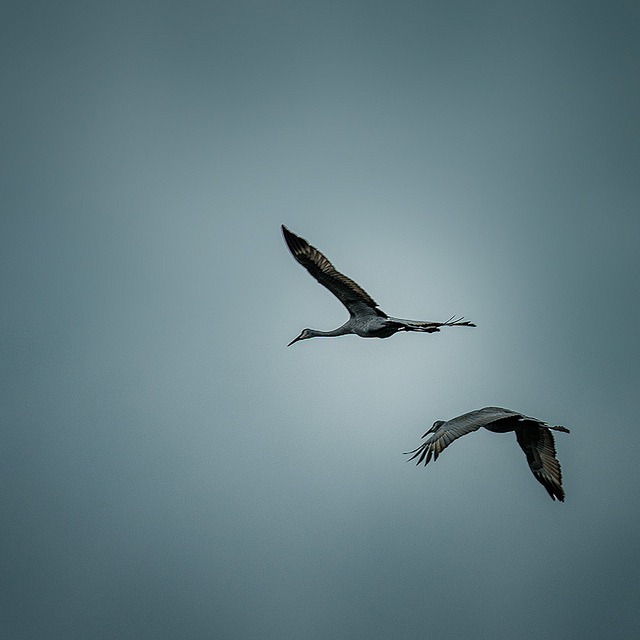<image>Why aren't there any feathers on its neck? It is unclear why there aren't any feathers on its neck. It could be due to a variety of reasons such as the bird was born that way, or they don't grow there. Why aren't there any feathers on its neck? I don't know why there aren't any feathers on its neck. It can be due to various reasons such as it is unknown, born that way, or fighting. 